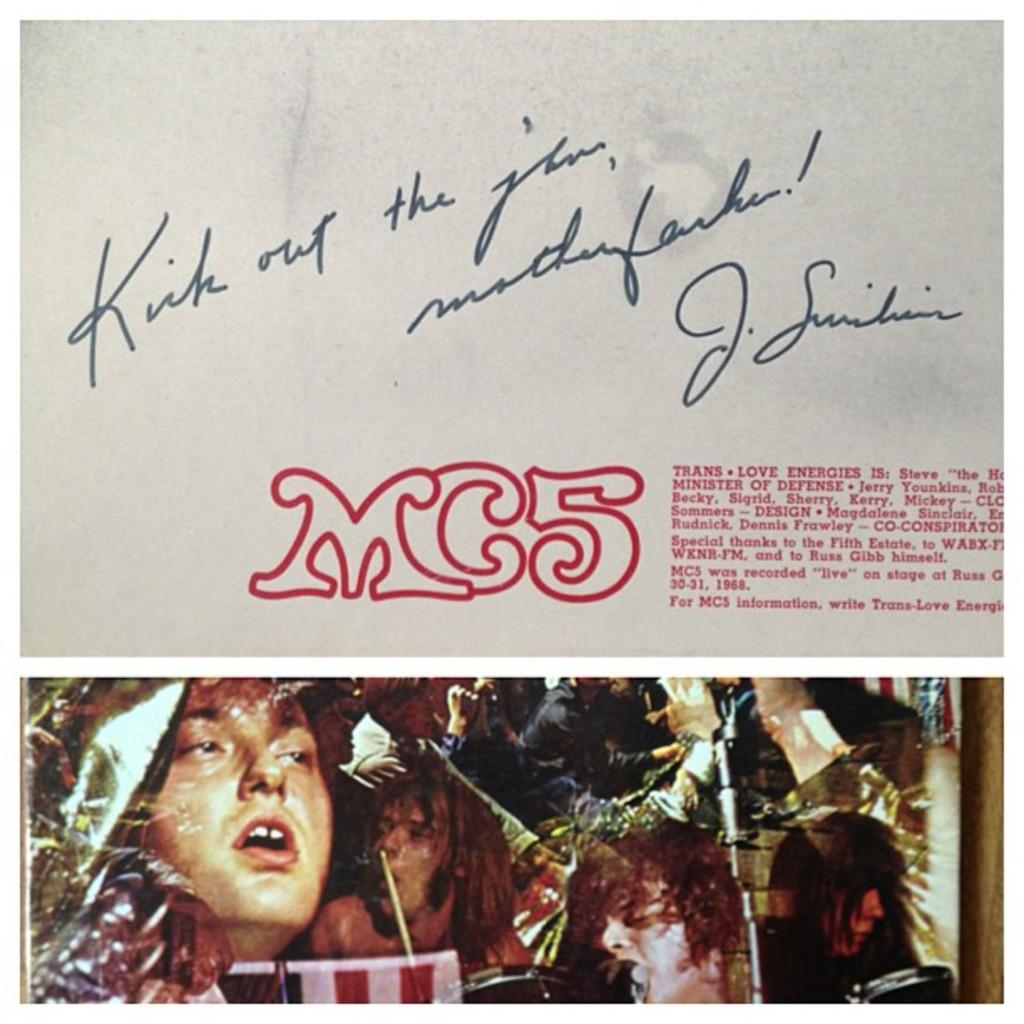What is written on the paper in the image? There is text written on a paper in the image. Can you describe the scene at the bottom of the image? There are persons and objects at the bottom of the image. What type of stocking is the fireman wearing in the image? There is no fireman or stocking present in the image. How hot is the temperature in the image? The image does not provide any information about the temperature, so it cannot be determined. 